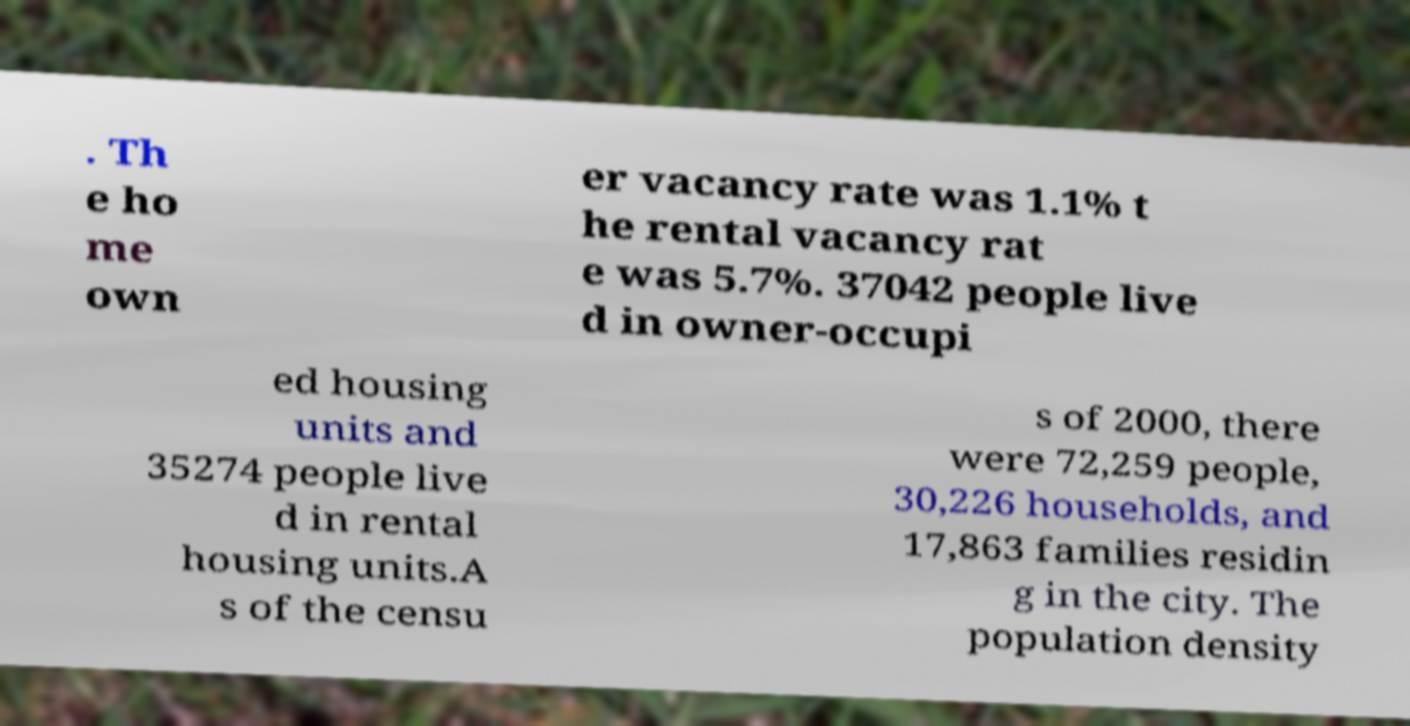What messages or text are displayed in this image? I need them in a readable, typed format. . Th e ho me own er vacancy rate was 1.1% t he rental vacancy rat e was 5.7%. 37042 people live d in owner-occupi ed housing units and 35274 people live d in rental housing units.A s of the censu s of 2000, there were 72,259 people, 30,226 households, and 17,863 families residin g in the city. The population density 